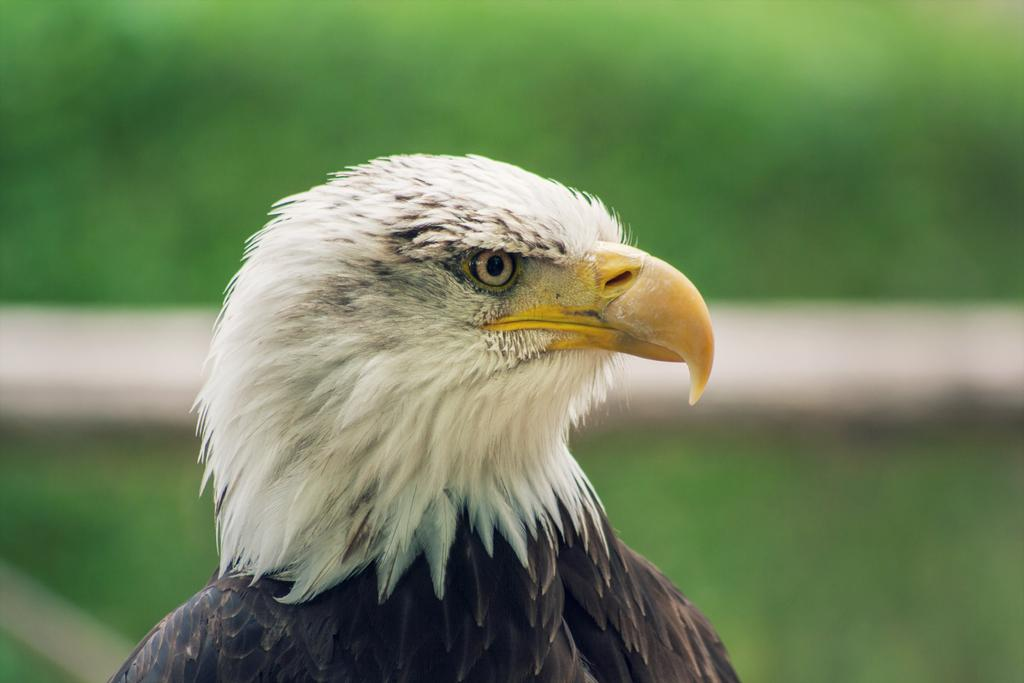What type of animal is in the image? There is a bird in the image. Can you describe the colors of the bird? The bird has yellow, black, and white colors. What can be observed about the background of the image? The background of the image is blurred. What type of truck is visible in the background of the image? There is no truck present in the image; it only features a bird with a blurred background. 